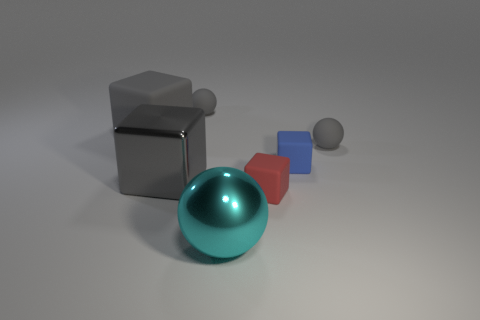What material is the cyan object?
Give a very brief answer. Metal. There is a rubber cube that is the same size as the cyan metal object; what is its color?
Ensure brevity in your answer.  Gray. There is a big matte object that is the same color as the shiny cube; what shape is it?
Offer a very short reply. Cube. Does the large gray rubber thing have the same shape as the large cyan object?
Your answer should be compact. No. What material is the sphere that is both to the left of the small red matte block and behind the cyan shiny ball?
Give a very brief answer. Rubber. How big is the blue rubber object?
Ensure brevity in your answer.  Small. There is a large rubber object that is the same shape as the gray metallic thing; what color is it?
Offer a terse response. Gray. Is there any other thing of the same color as the shiny sphere?
Provide a short and direct response. No. There is a gray rubber sphere left of the cyan thing; is its size the same as the cyan metallic thing on the left side of the blue rubber block?
Keep it short and to the point. No. Is the number of small cubes in front of the tiny red matte block the same as the number of gray things that are to the right of the large rubber thing?
Provide a succinct answer. No. 